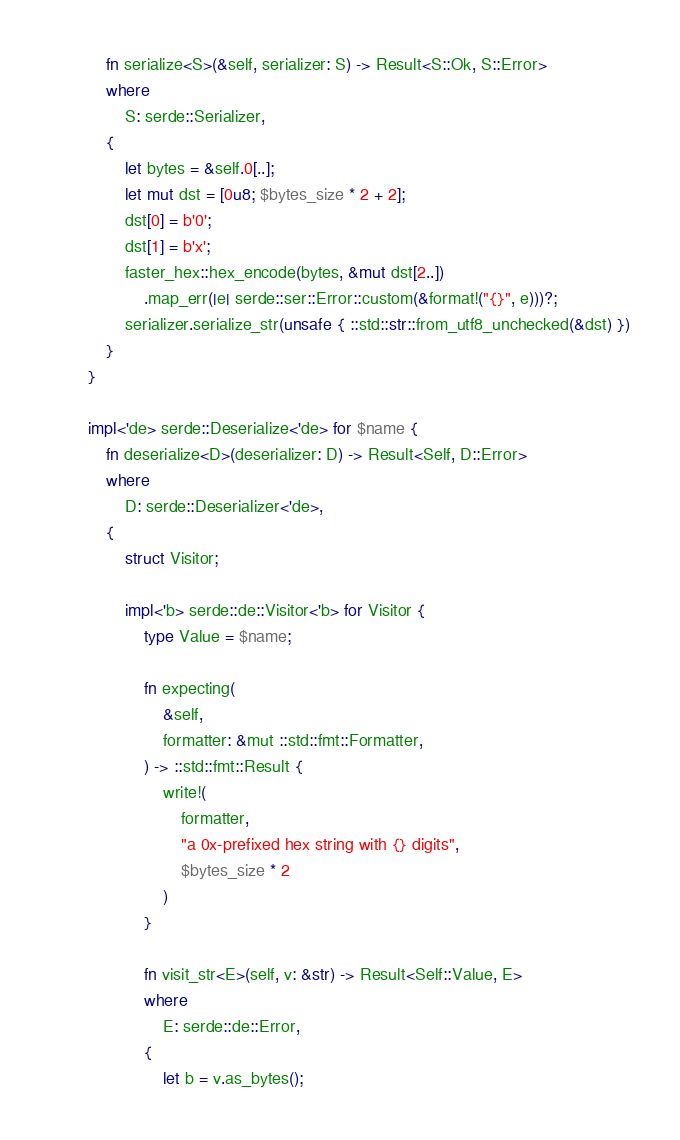<code> <loc_0><loc_0><loc_500><loc_500><_Rust_>            fn serialize<S>(&self, serializer: S) -> Result<S::Ok, S::Error>
            where
                S: serde::Serializer,
            {
                let bytes = &self.0[..];
                let mut dst = [0u8; $bytes_size * 2 + 2];
                dst[0] = b'0';
                dst[1] = b'x';
                faster_hex::hex_encode(bytes, &mut dst[2..])
                    .map_err(|e| serde::ser::Error::custom(&format!("{}", e)))?;
                serializer.serialize_str(unsafe { ::std::str::from_utf8_unchecked(&dst) })
            }
        }

        impl<'de> serde::Deserialize<'de> for $name {
            fn deserialize<D>(deserializer: D) -> Result<Self, D::Error>
            where
                D: serde::Deserializer<'de>,
            {
                struct Visitor;

                impl<'b> serde::de::Visitor<'b> for Visitor {
                    type Value = $name;

                    fn expecting(
                        &self,
                        formatter: &mut ::std::fmt::Formatter,
                    ) -> ::std::fmt::Result {
                        write!(
                            formatter,
                            "a 0x-prefixed hex string with {} digits",
                            $bytes_size * 2
                        )
                    }

                    fn visit_str<E>(self, v: &str) -> Result<Self::Value, E>
                    where
                        E: serde::de::Error,
                    {
                        let b = v.as_bytes();</code> 